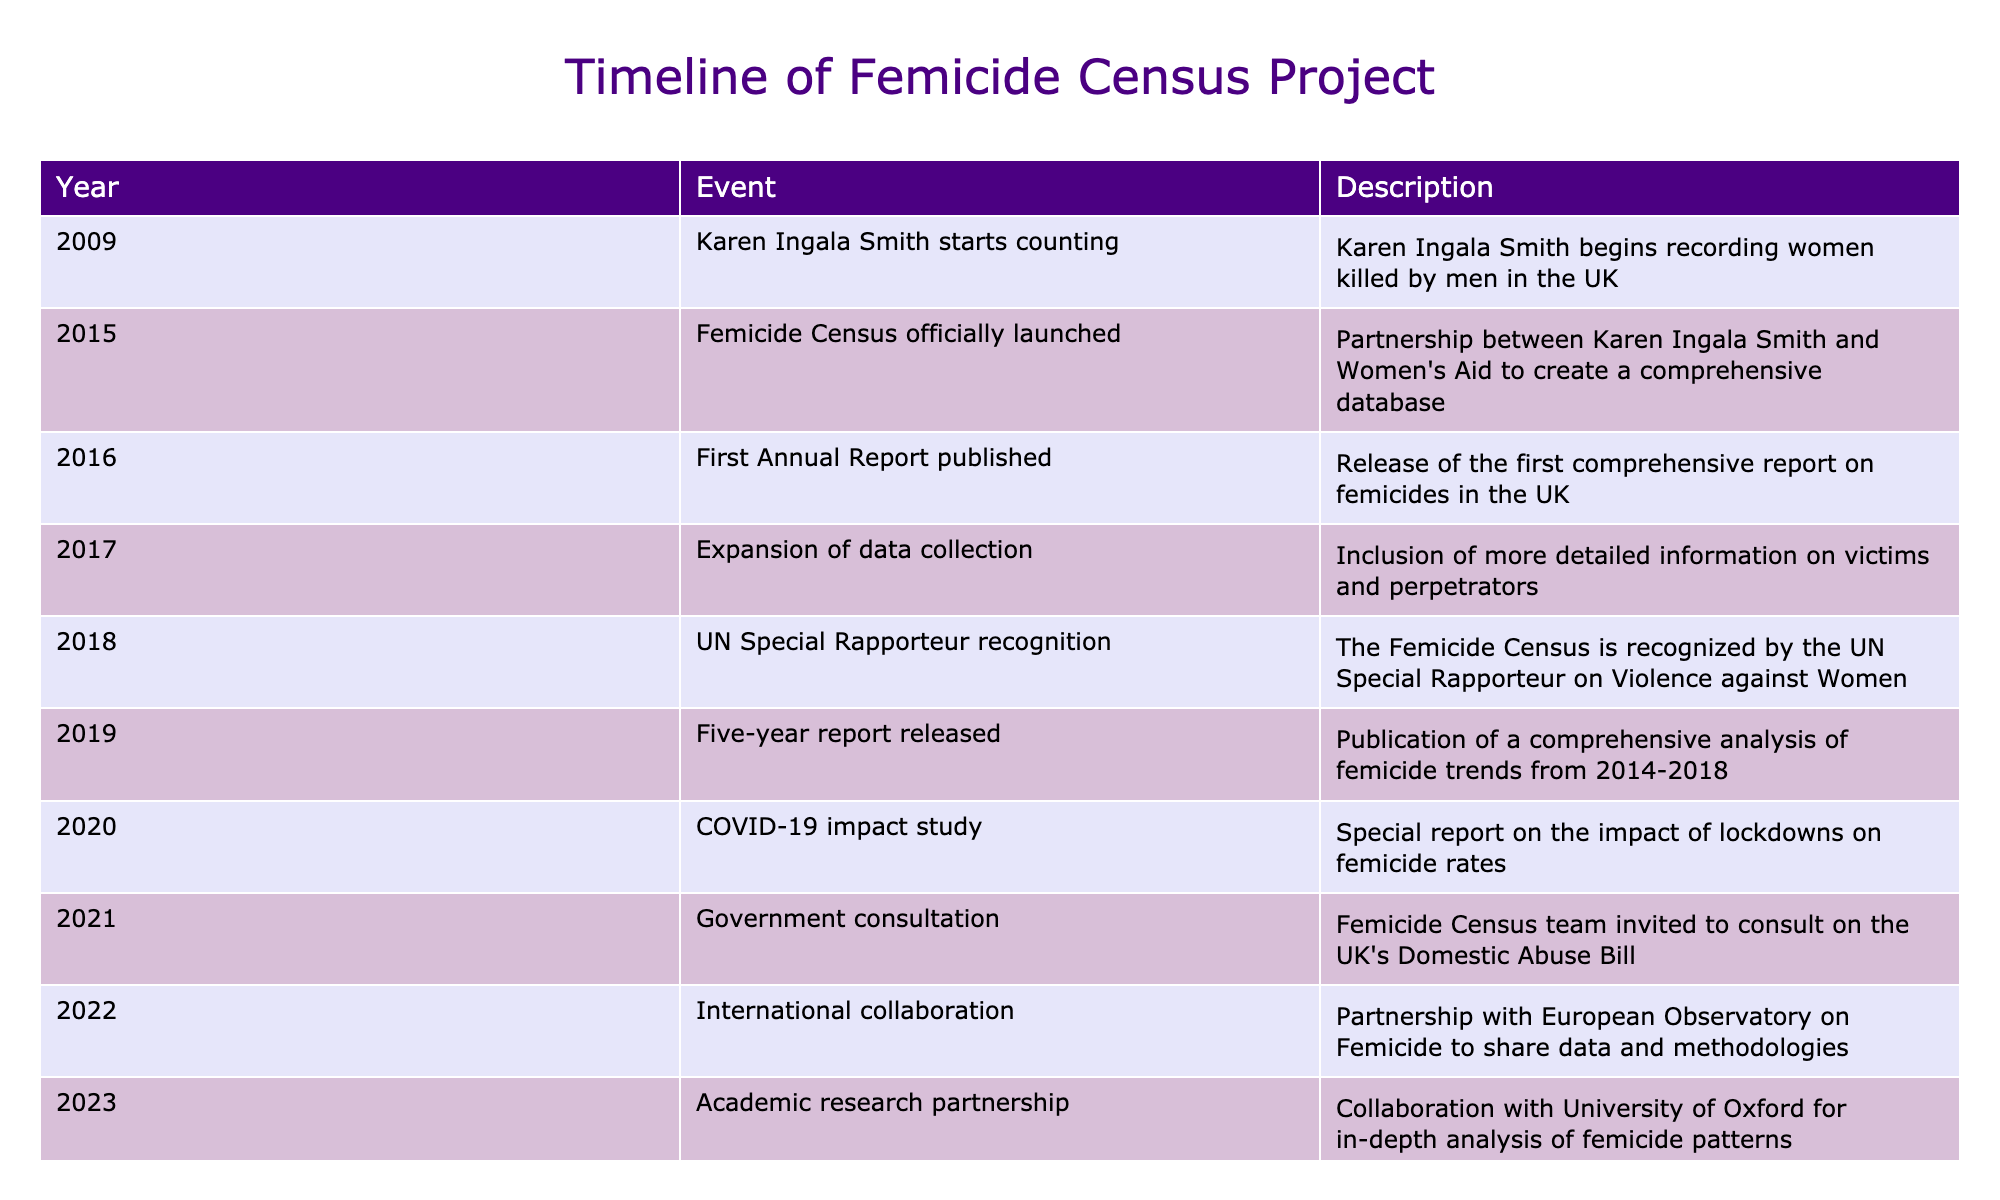What year did Karen Ingala Smith start counting women killed by men? The table lists "Karen Ingala Smith starts counting" in the year 2009, which directly answers the question.
Answer: 2009 What event occurred in 2015 related to the Femicide Census? According to the table, the event in 2015 is "Femicide Census officially launched," which indicates the formal initiation of the project.
Answer: Femicide Census officially launched How many years after launching was the first Annual Report published? The Femicide Census was launched in 2015, and the first Annual Report was published in 2016. Subtracting 2015 from 2016 gives us 1 year.
Answer: 1 year Did the Femicide Census receive recognition from the UN? The table indicates that in 2018, the Femicide Census was recognized by the UN Special Rapporteur on Violence against Women, confirming that it did receive recognition.
Answer: Yes What trend did the five-year report released in 2019 analyze? The five-year report launched in 2019 provided a comprehensive analysis of femicide trends from 2014-2018, suggesting it covered those specific years of data analysis.
Answer: Femicide trends from 2014-2018 What is the significance of the 2020 special report? The special report published in 2020 assessed the impact of lockdowns on femicide rates due to COVID-19, highlighting a contemporary issue affecting femicide statistics during the pandemic.
Answer: Impact of lockdowns on femicide rates What two partnerships were formed in 2022 and 2023? In 2022, the Femicide Census formed an international collaboration with the European Observatory on Femicide, and in 2023, they partnered with the University of Oxford for academic research. These two partnerships signify an expansion of their efforts in data sharing and research.
Answer: International collaboration in 2022 and academic research partnership in 2023 How does the expansion of data collection in 2017 improve the femicide records? The 2017 event notes "Expansion of data collection" and indicates the inclusion of more detailed information on victims and perpetrators. This suggests that the data has become more comprehensive, allowing for deeper insights into femicides.
Answer: More comprehensive data What is the longest time span covered by the reports noted in the table? The five-year report covers a span from 2014 to 2018 (5 years) while the timeline starts from 2009. Therefore, looking across all events listed, the longest time span mentioned regarding reports specifically is from 2014 to 2018, which is 5 years.
Answer: 5 years 